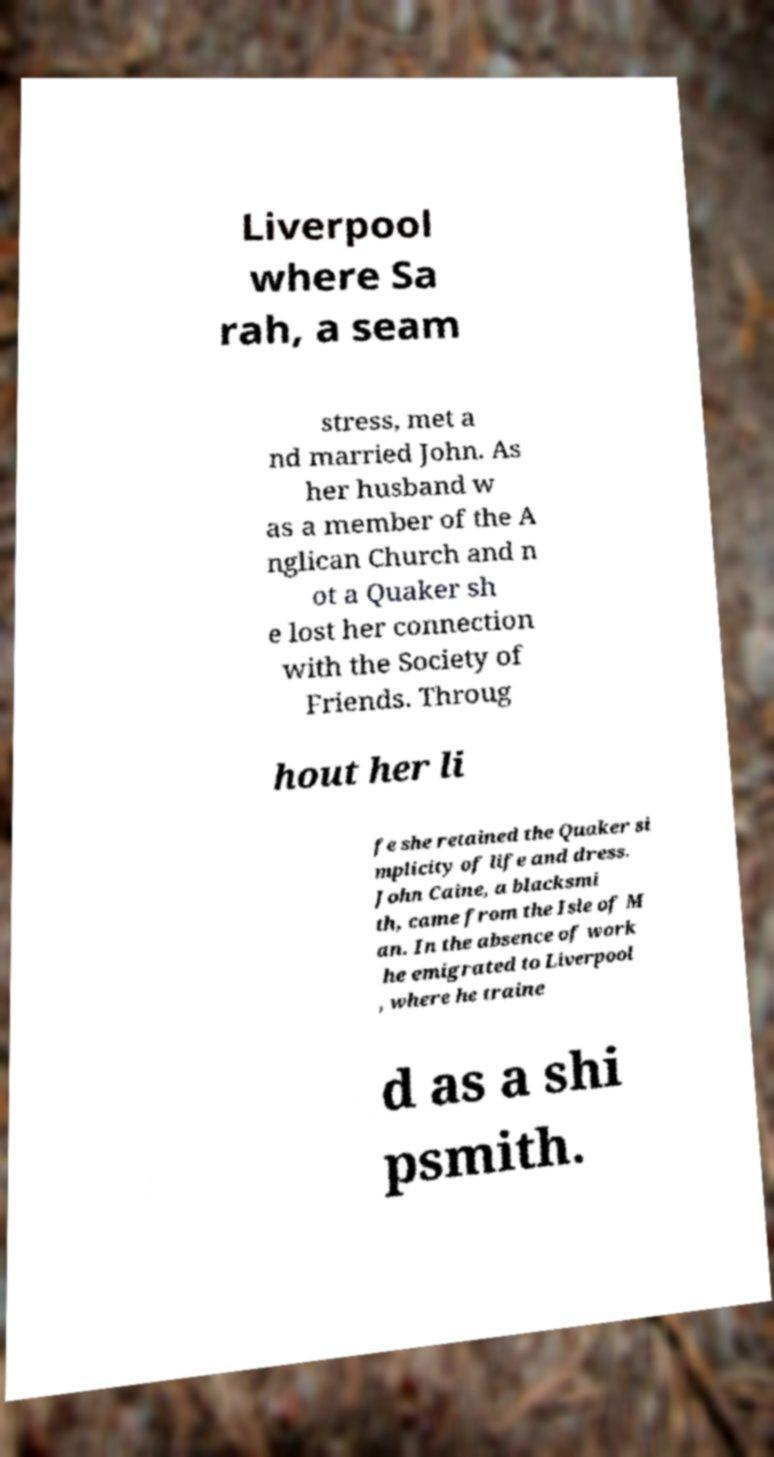Could you assist in decoding the text presented in this image and type it out clearly? Liverpool where Sa rah, a seam stress, met a nd married John. As her husband w as a member of the A nglican Church and n ot a Quaker sh e lost her connection with the Society of Friends. Throug hout her li fe she retained the Quaker si mplicity of life and dress. John Caine, a blacksmi th, came from the Isle of M an. In the absence of work he emigrated to Liverpool , where he traine d as a shi psmith. 